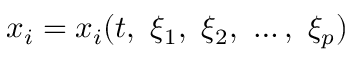<formula> <loc_0><loc_0><loc_500><loc_500>x _ { i } = x _ { i } ( t , \ \xi _ { 1 } , \ \xi _ { 2 } , \ \dots , \ \xi _ { p } )</formula> 